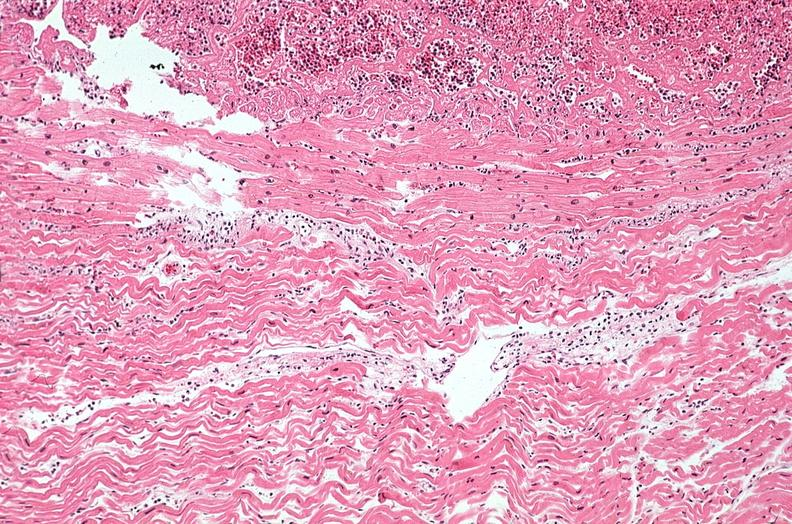what does this image show?
Answer the question using a single word or phrase. Heart 